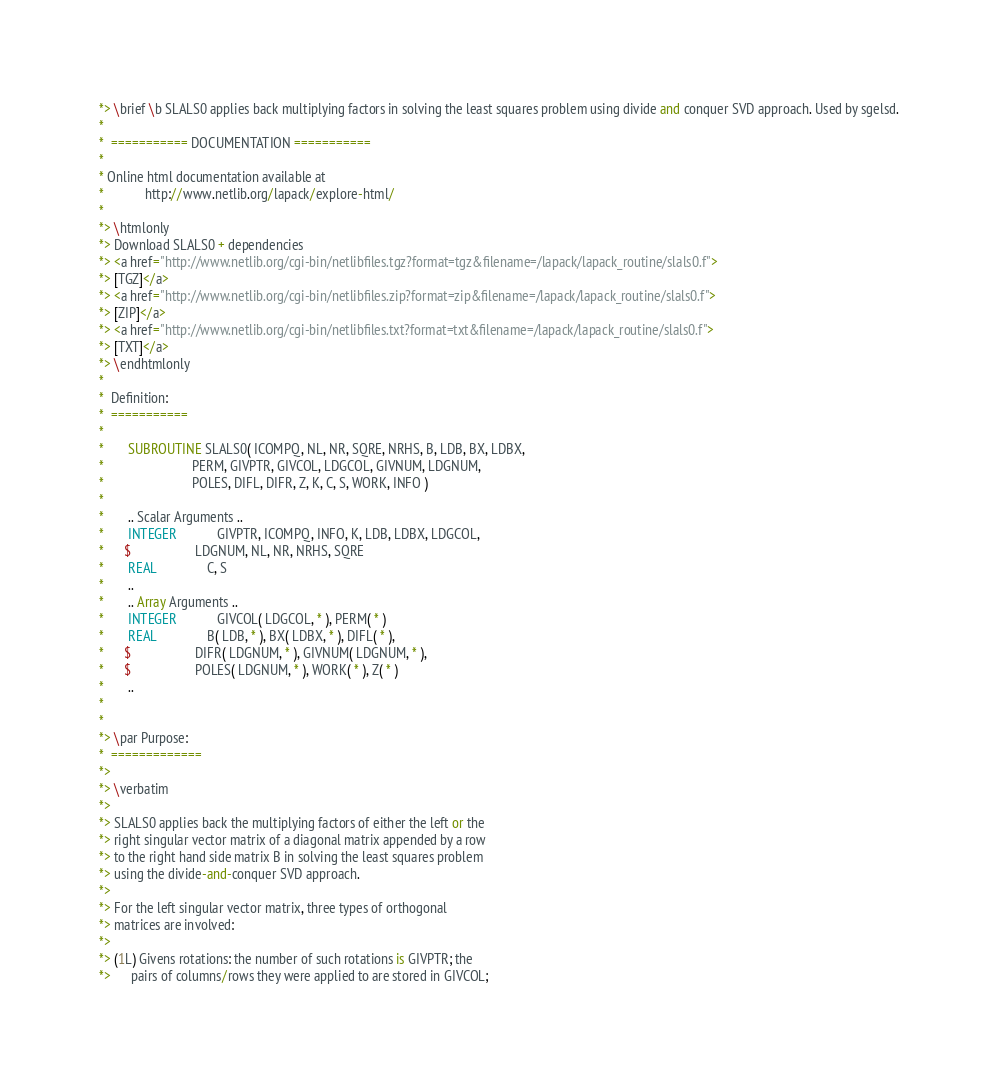Convert code to text. <code><loc_0><loc_0><loc_500><loc_500><_FORTRAN_>*> \brief \b SLALS0 applies back multiplying factors in solving the least squares problem using divide and conquer SVD approach. Used by sgelsd.
*
*  =========== DOCUMENTATION ===========
*
* Online html documentation available at
*            http://www.netlib.org/lapack/explore-html/
*
*> \htmlonly
*> Download SLALS0 + dependencies
*> <a href="http://www.netlib.org/cgi-bin/netlibfiles.tgz?format=tgz&filename=/lapack/lapack_routine/slals0.f">
*> [TGZ]</a>
*> <a href="http://www.netlib.org/cgi-bin/netlibfiles.zip?format=zip&filename=/lapack/lapack_routine/slals0.f">
*> [ZIP]</a>
*> <a href="http://www.netlib.org/cgi-bin/netlibfiles.txt?format=txt&filename=/lapack/lapack_routine/slals0.f">
*> [TXT]</a>
*> \endhtmlonly
*
*  Definition:
*  ===========
*
*       SUBROUTINE SLALS0( ICOMPQ, NL, NR, SQRE, NRHS, B, LDB, BX, LDBX,
*                          PERM, GIVPTR, GIVCOL, LDGCOL, GIVNUM, LDGNUM,
*                          POLES, DIFL, DIFR, Z, K, C, S, WORK, INFO )
*
*       .. Scalar Arguments ..
*       INTEGER            GIVPTR, ICOMPQ, INFO, K, LDB, LDBX, LDGCOL,
*      $                   LDGNUM, NL, NR, NRHS, SQRE
*       REAL               C, S
*       ..
*       .. Array Arguments ..
*       INTEGER            GIVCOL( LDGCOL, * ), PERM( * )
*       REAL               B( LDB, * ), BX( LDBX, * ), DIFL( * ),
*      $                   DIFR( LDGNUM, * ), GIVNUM( LDGNUM, * ),
*      $                   POLES( LDGNUM, * ), WORK( * ), Z( * )
*       ..
*
*
*> \par Purpose:
*  =============
*>
*> \verbatim
*>
*> SLALS0 applies back the multiplying factors of either the left or the
*> right singular vector matrix of a diagonal matrix appended by a row
*> to the right hand side matrix B in solving the least squares problem
*> using the divide-and-conquer SVD approach.
*>
*> For the left singular vector matrix, three types of orthogonal
*> matrices are involved:
*>
*> (1L) Givens rotations: the number of such rotations is GIVPTR; the
*>      pairs of columns/rows they were applied to are stored in GIVCOL;</code> 